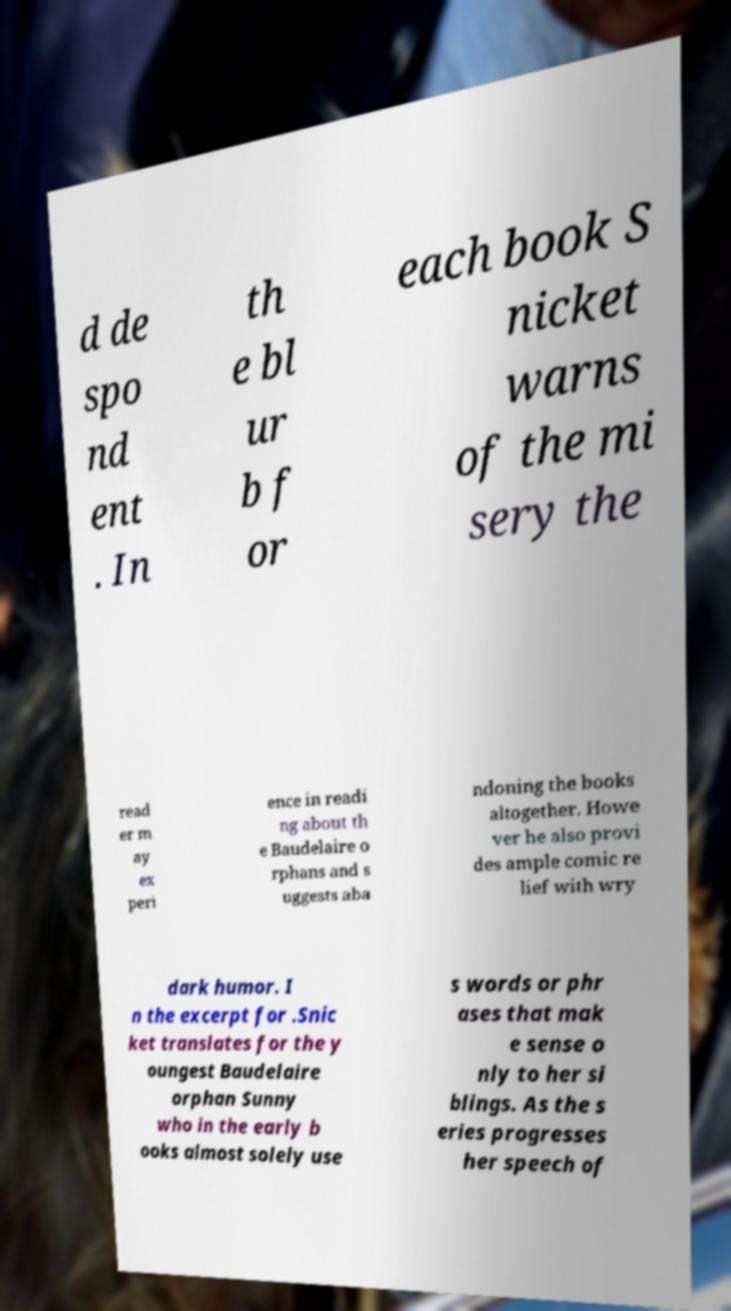Could you extract and type out the text from this image? d de spo nd ent . In th e bl ur b f or each book S nicket warns of the mi sery the read er m ay ex peri ence in readi ng about th e Baudelaire o rphans and s uggests aba ndoning the books altogether. Howe ver he also provi des ample comic re lief with wry dark humor. I n the excerpt for .Snic ket translates for the y oungest Baudelaire orphan Sunny who in the early b ooks almost solely use s words or phr ases that mak e sense o nly to her si blings. As the s eries progresses her speech of 